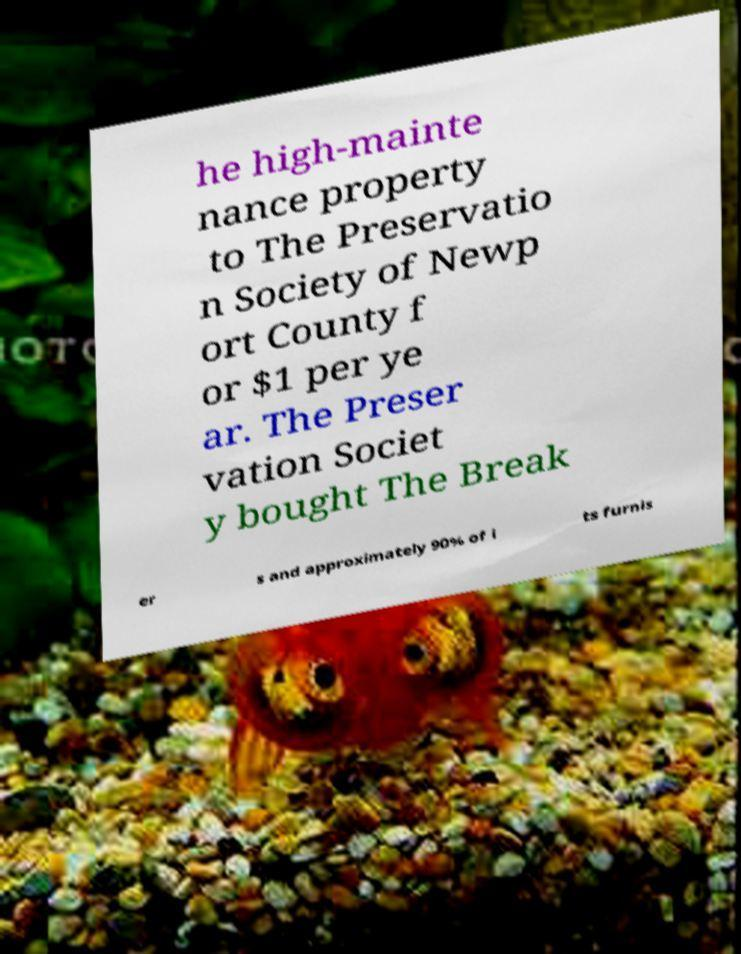Please identify and transcribe the text found in this image. he high-mainte nance property to The Preservatio n Society of Newp ort County f or $1 per ye ar. The Preser vation Societ y bought The Break er s and approximately 90% of i ts furnis 